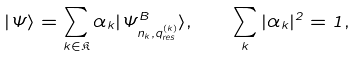<formula> <loc_0><loc_0><loc_500><loc_500>| \Psi \rangle = \sum _ { k \in \mathfrak { K } } \alpha _ { k } | \Psi ^ { B } _ { n _ { k } , q ^ { ( k ) } _ { r e s } } \rangle , \quad \sum _ { k } | \alpha _ { k } | ^ { 2 } = 1 ,</formula> 